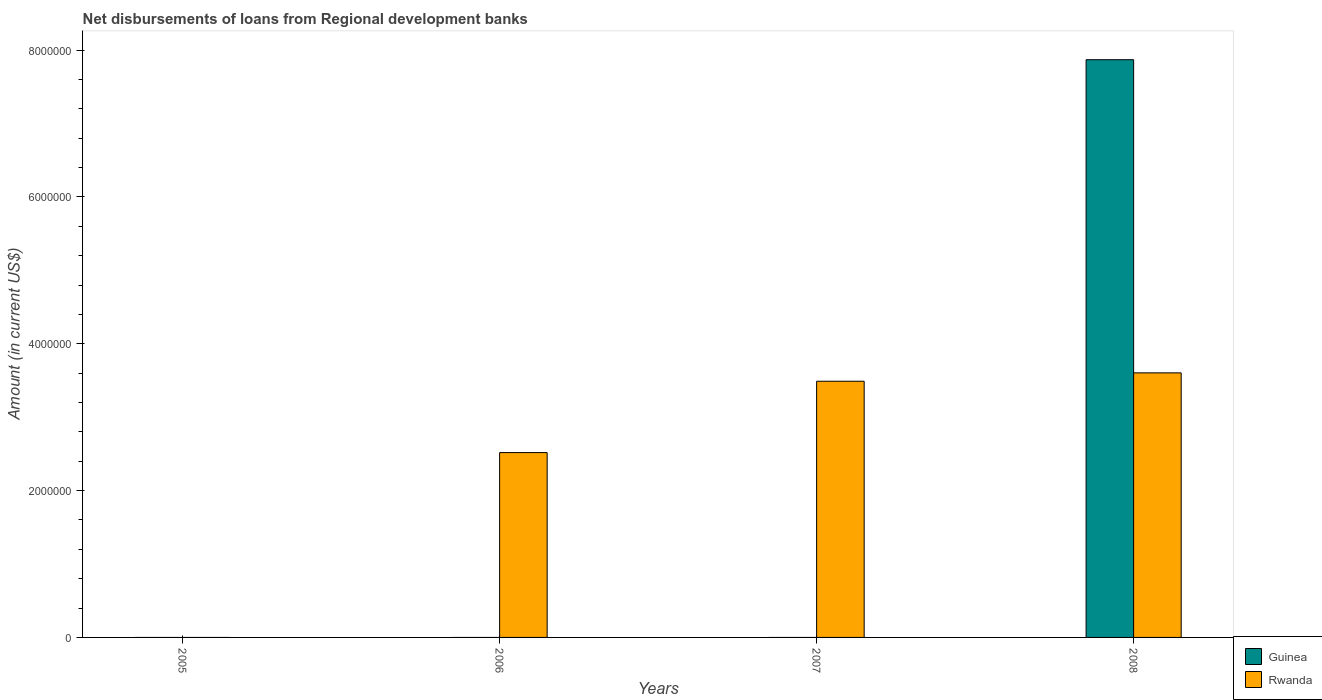Are the number of bars per tick equal to the number of legend labels?
Give a very brief answer. No. Are the number of bars on each tick of the X-axis equal?
Offer a terse response. No. How many bars are there on the 4th tick from the left?
Provide a succinct answer. 2. How many bars are there on the 2nd tick from the right?
Give a very brief answer. 1. In how many cases, is the number of bars for a given year not equal to the number of legend labels?
Give a very brief answer. 3. What is the amount of disbursements of loans from regional development banks in Rwanda in 2007?
Give a very brief answer. 3.49e+06. Across all years, what is the maximum amount of disbursements of loans from regional development banks in Rwanda?
Your answer should be very brief. 3.60e+06. Across all years, what is the minimum amount of disbursements of loans from regional development banks in Rwanda?
Ensure brevity in your answer.  0. In which year was the amount of disbursements of loans from regional development banks in Guinea maximum?
Provide a succinct answer. 2008. What is the total amount of disbursements of loans from regional development banks in Rwanda in the graph?
Make the answer very short. 9.61e+06. What is the difference between the amount of disbursements of loans from regional development banks in Rwanda in 2007 and that in 2008?
Give a very brief answer. -1.14e+05. What is the difference between the amount of disbursements of loans from regional development banks in Rwanda in 2007 and the amount of disbursements of loans from regional development banks in Guinea in 2006?
Make the answer very short. 3.49e+06. What is the average amount of disbursements of loans from regional development banks in Rwanda per year?
Ensure brevity in your answer.  2.40e+06. In the year 2008, what is the difference between the amount of disbursements of loans from regional development banks in Guinea and amount of disbursements of loans from regional development banks in Rwanda?
Make the answer very short. 4.27e+06. In how many years, is the amount of disbursements of loans from regional development banks in Guinea greater than 400000 US$?
Your response must be concise. 1. What is the ratio of the amount of disbursements of loans from regional development banks in Rwanda in 2007 to that in 2008?
Keep it short and to the point. 0.97. What is the difference between the highest and the second highest amount of disbursements of loans from regional development banks in Rwanda?
Offer a very short reply. 1.14e+05. What is the difference between the highest and the lowest amount of disbursements of loans from regional development banks in Rwanda?
Provide a succinct answer. 3.60e+06. In how many years, is the amount of disbursements of loans from regional development banks in Guinea greater than the average amount of disbursements of loans from regional development banks in Guinea taken over all years?
Keep it short and to the point. 1. Is the sum of the amount of disbursements of loans from regional development banks in Rwanda in 2007 and 2008 greater than the maximum amount of disbursements of loans from regional development banks in Guinea across all years?
Make the answer very short. No. How many bars are there?
Offer a terse response. 4. Are the values on the major ticks of Y-axis written in scientific E-notation?
Your answer should be very brief. No. Does the graph contain grids?
Provide a succinct answer. No. Where does the legend appear in the graph?
Give a very brief answer. Bottom right. What is the title of the graph?
Provide a short and direct response. Net disbursements of loans from Regional development banks. What is the label or title of the X-axis?
Offer a very short reply. Years. What is the Amount (in current US$) of Rwanda in 2005?
Keep it short and to the point. 0. What is the Amount (in current US$) of Guinea in 2006?
Your answer should be compact. 0. What is the Amount (in current US$) of Rwanda in 2006?
Give a very brief answer. 2.52e+06. What is the Amount (in current US$) of Guinea in 2007?
Offer a very short reply. 0. What is the Amount (in current US$) of Rwanda in 2007?
Make the answer very short. 3.49e+06. What is the Amount (in current US$) of Guinea in 2008?
Ensure brevity in your answer.  7.87e+06. What is the Amount (in current US$) of Rwanda in 2008?
Provide a short and direct response. 3.60e+06. Across all years, what is the maximum Amount (in current US$) of Guinea?
Offer a terse response. 7.87e+06. Across all years, what is the maximum Amount (in current US$) in Rwanda?
Offer a very short reply. 3.60e+06. Across all years, what is the minimum Amount (in current US$) of Guinea?
Offer a terse response. 0. Across all years, what is the minimum Amount (in current US$) in Rwanda?
Make the answer very short. 0. What is the total Amount (in current US$) in Guinea in the graph?
Offer a terse response. 7.87e+06. What is the total Amount (in current US$) of Rwanda in the graph?
Your answer should be very brief. 9.61e+06. What is the difference between the Amount (in current US$) in Rwanda in 2006 and that in 2007?
Ensure brevity in your answer.  -9.72e+05. What is the difference between the Amount (in current US$) in Rwanda in 2006 and that in 2008?
Give a very brief answer. -1.09e+06. What is the difference between the Amount (in current US$) in Rwanda in 2007 and that in 2008?
Offer a very short reply. -1.14e+05. What is the average Amount (in current US$) in Guinea per year?
Ensure brevity in your answer.  1.97e+06. What is the average Amount (in current US$) in Rwanda per year?
Your response must be concise. 2.40e+06. In the year 2008, what is the difference between the Amount (in current US$) of Guinea and Amount (in current US$) of Rwanda?
Make the answer very short. 4.27e+06. What is the ratio of the Amount (in current US$) in Rwanda in 2006 to that in 2007?
Give a very brief answer. 0.72. What is the ratio of the Amount (in current US$) in Rwanda in 2006 to that in 2008?
Give a very brief answer. 0.7. What is the ratio of the Amount (in current US$) of Rwanda in 2007 to that in 2008?
Offer a very short reply. 0.97. What is the difference between the highest and the second highest Amount (in current US$) of Rwanda?
Your answer should be very brief. 1.14e+05. What is the difference between the highest and the lowest Amount (in current US$) of Guinea?
Your answer should be compact. 7.87e+06. What is the difference between the highest and the lowest Amount (in current US$) of Rwanda?
Provide a short and direct response. 3.60e+06. 